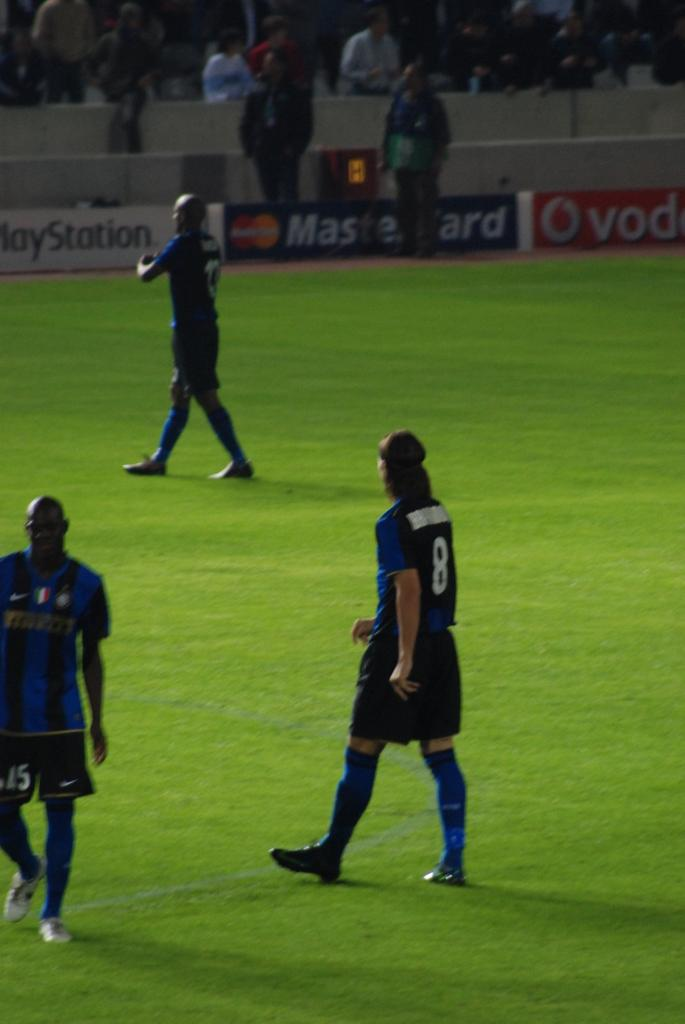<image>
Present a compact description of the photo's key features. Three soccer players from the same team are on the field in those included are players 8 and 15. 